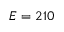Convert formula to latex. <formula><loc_0><loc_0><loc_500><loc_500>E = 2 1 0</formula> 